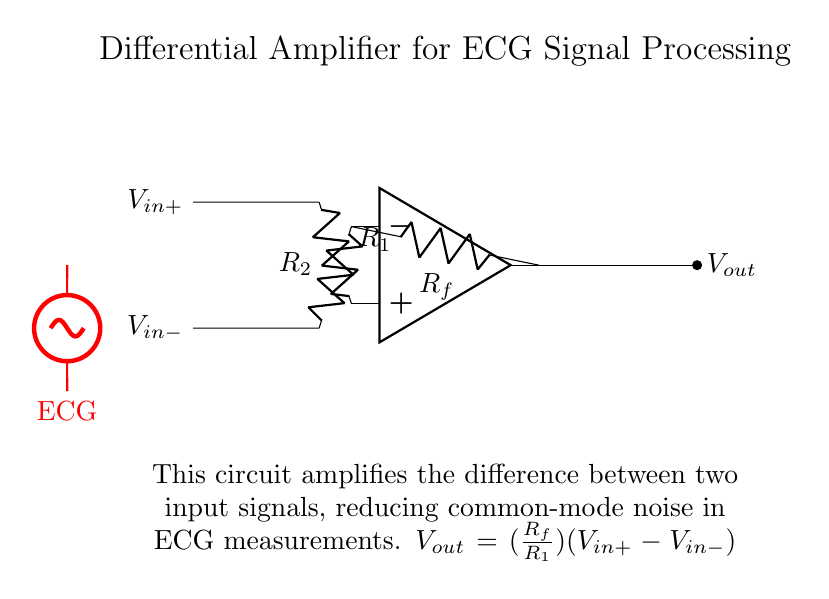What type of amplifier is shown in the circuit? The circuit represents a differential amplifier, which is designed to amplify the difference between two input signals while rejecting common-mode noise.
Answer: Differential amplifier What are the values of the resistors used in the circuit? The resistors present are labeled as R1, R2, and Rf. The specific numerical values of these resistors are not provided in the diagram, but they are critical for setting the gain of the amplifier.
Answer: R1, R2, Rf What is the role of Rf in this circuit? The resistor Rf is the feedback resistor and determines the gain of the amplifier along with R1. It creates a feedback loop that stabilizes the output relative to the input differences.
Answer: Feedback resistor What is the output voltage formula for this amplifier? The output voltage is calculated using the formula Vout equals the gain multiplied by the difference between the input voltages Vin plus and Vin minus, given specifically as Vout equals (Rf over R1)(Vin plus minus Vin minus).
Answer: Vout equals (Rf over R1)(Vin plus minus Vin minus) How does this circuit improve ECG signal acquisition? This differential amplifier reduces common-mode noise that can corrupt ECG signals, allowing for clear signal amplification by focusing on the difference between the two input signals.
Answer: Reduces common-mode noise What is the significance of the red sinusoidal voltage source in the diagram? The red sinusoidal voltage source represents the ECG signal input, illustrating the type of signal the circuit is designed to process, which is typically a fluctuating electrical potential generated by heartbeats.
Answer: ECG signal input Why are both input terminals labeled Vin plus and Vin minus? The labeling indicates that this amplifier operates on a differential input mechanism, where Vin plus refers to the positive input and Vin minus refers to the negative input, facilitating the difference measurement essential for the circuit's operation.
Answer: Positive and negative inputs 